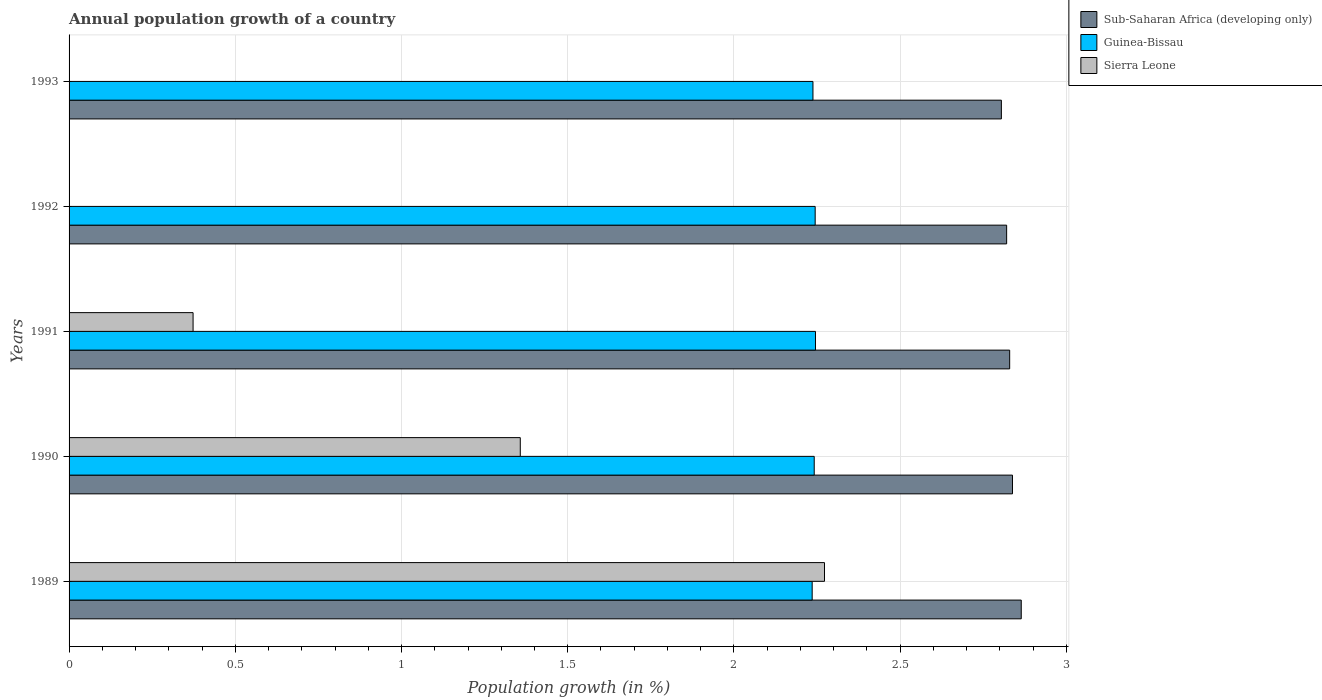How many different coloured bars are there?
Your response must be concise. 3. How many groups of bars are there?
Give a very brief answer. 5. Are the number of bars per tick equal to the number of legend labels?
Offer a very short reply. No. How many bars are there on the 3rd tick from the bottom?
Your response must be concise. 3. What is the label of the 5th group of bars from the top?
Your answer should be compact. 1989. In how many cases, is the number of bars for a given year not equal to the number of legend labels?
Keep it short and to the point. 2. What is the annual population growth in Guinea-Bissau in 1990?
Keep it short and to the point. 2.24. Across all years, what is the maximum annual population growth in Sub-Saharan Africa (developing only)?
Offer a terse response. 2.86. Across all years, what is the minimum annual population growth in Sierra Leone?
Make the answer very short. 0. What is the total annual population growth in Sierra Leone in the graph?
Provide a succinct answer. 4. What is the difference between the annual population growth in Sub-Saharan Africa (developing only) in 1989 and that in 1990?
Your answer should be compact. 0.03. What is the difference between the annual population growth in Sub-Saharan Africa (developing only) in 1990 and the annual population growth in Guinea-Bissau in 1989?
Your answer should be compact. 0.6. What is the average annual population growth in Sub-Saharan Africa (developing only) per year?
Give a very brief answer. 2.83. In the year 1991, what is the difference between the annual population growth in Guinea-Bissau and annual population growth in Sierra Leone?
Your response must be concise. 1.87. What is the ratio of the annual population growth in Sub-Saharan Africa (developing only) in 1989 to that in 1991?
Your answer should be compact. 1.01. Is the annual population growth in Guinea-Bissau in 1989 less than that in 1991?
Offer a terse response. Yes. What is the difference between the highest and the second highest annual population growth in Guinea-Bissau?
Your answer should be very brief. 0. What is the difference between the highest and the lowest annual population growth in Sub-Saharan Africa (developing only)?
Offer a terse response. 0.06. Is the sum of the annual population growth in Guinea-Bissau in 1992 and 1993 greater than the maximum annual population growth in Sub-Saharan Africa (developing only) across all years?
Your answer should be compact. Yes. Is it the case that in every year, the sum of the annual population growth in Guinea-Bissau and annual population growth in Sierra Leone is greater than the annual population growth in Sub-Saharan Africa (developing only)?
Give a very brief answer. No. How many bars are there?
Ensure brevity in your answer.  13. Are all the bars in the graph horizontal?
Provide a succinct answer. Yes. Where does the legend appear in the graph?
Your response must be concise. Top right. What is the title of the graph?
Ensure brevity in your answer.  Annual population growth of a country. What is the label or title of the X-axis?
Keep it short and to the point. Population growth (in %). What is the label or title of the Y-axis?
Provide a short and direct response. Years. What is the Population growth (in %) of Sub-Saharan Africa (developing only) in 1989?
Give a very brief answer. 2.86. What is the Population growth (in %) in Guinea-Bissau in 1989?
Offer a terse response. 2.24. What is the Population growth (in %) in Sierra Leone in 1989?
Give a very brief answer. 2.27. What is the Population growth (in %) in Sub-Saharan Africa (developing only) in 1990?
Provide a succinct answer. 2.84. What is the Population growth (in %) of Guinea-Bissau in 1990?
Offer a terse response. 2.24. What is the Population growth (in %) of Sierra Leone in 1990?
Offer a very short reply. 1.36. What is the Population growth (in %) of Sub-Saharan Africa (developing only) in 1991?
Your response must be concise. 2.83. What is the Population growth (in %) of Guinea-Bissau in 1991?
Make the answer very short. 2.25. What is the Population growth (in %) in Sierra Leone in 1991?
Offer a terse response. 0.37. What is the Population growth (in %) in Sub-Saharan Africa (developing only) in 1992?
Provide a succinct answer. 2.82. What is the Population growth (in %) in Guinea-Bissau in 1992?
Provide a succinct answer. 2.24. What is the Population growth (in %) of Sierra Leone in 1992?
Ensure brevity in your answer.  0. What is the Population growth (in %) in Sub-Saharan Africa (developing only) in 1993?
Your answer should be very brief. 2.8. What is the Population growth (in %) in Guinea-Bissau in 1993?
Your answer should be compact. 2.24. Across all years, what is the maximum Population growth (in %) of Sub-Saharan Africa (developing only)?
Offer a terse response. 2.86. Across all years, what is the maximum Population growth (in %) in Guinea-Bissau?
Provide a succinct answer. 2.25. Across all years, what is the maximum Population growth (in %) in Sierra Leone?
Provide a succinct answer. 2.27. Across all years, what is the minimum Population growth (in %) of Sub-Saharan Africa (developing only)?
Provide a succinct answer. 2.8. Across all years, what is the minimum Population growth (in %) in Guinea-Bissau?
Give a very brief answer. 2.24. What is the total Population growth (in %) in Sub-Saharan Africa (developing only) in the graph?
Offer a terse response. 14.16. What is the total Population growth (in %) in Guinea-Bissau in the graph?
Your response must be concise. 11.2. What is the total Population growth (in %) of Sierra Leone in the graph?
Provide a succinct answer. 4. What is the difference between the Population growth (in %) of Sub-Saharan Africa (developing only) in 1989 and that in 1990?
Keep it short and to the point. 0.03. What is the difference between the Population growth (in %) of Guinea-Bissau in 1989 and that in 1990?
Ensure brevity in your answer.  -0.01. What is the difference between the Population growth (in %) in Sierra Leone in 1989 and that in 1990?
Keep it short and to the point. 0.92. What is the difference between the Population growth (in %) in Sub-Saharan Africa (developing only) in 1989 and that in 1991?
Your answer should be very brief. 0.03. What is the difference between the Population growth (in %) of Guinea-Bissau in 1989 and that in 1991?
Provide a short and direct response. -0.01. What is the difference between the Population growth (in %) in Sierra Leone in 1989 and that in 1991?
Provide a short and direct response. 1.9. What is the difference between the Population growth (in %) of Sub-Saharan Africa (developing only) in 1989 and that in 1992?
Keep it short and to the point. 0.04. What is the difference between the Population growth (in %) of Guinea-Bissau in 1989 and that in 1992?
Ensure brevity in your answer.  -0.01. What is the difference between the Population growth (in %) of Sub-Saharan Africa (developing only) in 1989 and that in 1993?
Your response must be concise. 0.06. What is the difference between the Population growth (in %) in Guinea-Bissau in 1989 and that in 1993?
Offer a very short reply. -0. What is the difference between the Population growth (in %) of Sub-Saharan Africa (developing only) in 1990 and that in 1991?
Keep it short and to the point. 0.01. What is the difference between the Population growth (in %) of Guinea-Bissau in 1990 and that in 1991?
Your response must be concise. -0. What is the difference between the Population growth (in %) of Sierra Leone in 1990 and that in 1991?
Your answer should be compact. 0.98. What is the difference between the Population growth (in %) in Sub-Saharan Africa (developing only) in 1990 and that in 1992?
Your answer should be very brief. 0.02. What is the difference between the Population growth (in %) in Guinea-Bissau in 1990 and that in 1992?
Your answer should be very brief. -0. What is the difference between the Population growth (in %) of Sub-Saharan Africa (developing only) in 1990 and that in 1993?
Offer a very short reply. 0.03. What is the difference between the Population growth (in %) of Guinea-Bissau in 1990 and that in 1993?
Your answer should be very brief. 0. What is the difference between the Population growth (in %) in Sub-Saharan Africa (developing only) in 1991 and that in 1992?
Your answer should be compact. 0.01. What is the difference between the Population growth (in %) of Guinea-Bissau in 1991 and that in 1992?
Your answer should be very brief. 0. What is the difference between the Population growth (in %) of Sub-Saharan Africa (developing only) in 1991 and that in 1993?
Offer a terse response. 0.03. What is the difference between the Population growth (in %) of Guinea-Bissau in 1991 and that in 1993?
Offer a very short reply. 0.01. What is the difference between the Population growth (in %) of Sub-Saharan Africa (developing only) in 1992 and that in 1993?
Provide a short and direct response. 0.02. What is the difference between the Population growth (in %) of Guinea-Bissau in 1992 and that in 1993?
Your answer should be compact. 0.01. What is the difference between the Population growth (in %) in Sub-Saharan Africa (developing only) in 1989 and the Population growth (in %) in Guinea-Bissau in 1990?
Provide a succinct answer. 0.62. What is the difference between the Population growth (in %) in Sub-Saharan Africa (developing only) in 1989 and the Population growth (in %) in Sierra Leone in 1990?
Give a very brief answer. 1.51. What is the difference between the Population growth (in %) of Guinea-Bissau in 1989 and the Population growth (in %) of Sierra Leone in 1990?
Keep it short and to the point. 0.88. What is the difference between the Population growth (in %) of Sub-Saharan Africa (developing only) in 1989 and the Population growth (in %) of Guinea-Bissau in 1991?
Your response must be concise. 0.62. What is the difference between the Population growth (in %) in Sub-Saharan Africa (developing only) in 1989 and the Population growth (in %) in Sierra Leone in 1991?
Provide a short and direct response. 2.49. What is the difference between the Population growth (in %) in Guinea-Bissau in 1989 and the Population growth (in %) in Sierra Leone in 1991?
Provide a short and direct response. 1.86. What is the difference between the Population growth (in %) in Sub-Saharan Africa (developing only) in 1989 and the Population growth (in %) in Guinea-Bissau in 1992?
Provide a succinct answer. 0.62. What is the difference between the Population growth (in %) in Sub-Saharan Africa (developing only) in 1989 and the Population growth (in %) in Guinea-Bissau in 1993?
Give a very brief answer. 0.63. What is the difference between the Population growth (in %) of Sub-Saharan Africa (developing only) in 1990 and the Population growth (in %) of Guinea-Bissau in 1991?
Your answer should be very brief. 0.59. What is the difference between the Population growth (in %) in Sub-Saharan Africa (developing only) in 1990 and the Population growth (in %) in Sierra Leone in 1991?
Your answer should be very brief. 2.46. What is the difference between the Population growth (in %) of Guinea-Bissau in 1990 and the Population growth (in %) of Sierra Leone in 1991?
Keep it short and to the point. 1.87. What is the difference between the Population growth (in %) in Sub-Saharan Africa (developing only) in 1990 and the Population growth (in %) in Guinea-Bissau in 1992?
Provide a short and direct response. 0.59. What is the difference between the Population growth (in %) of Sub-Saharan Africa (developing only) in 1990 and the Population growth (in %) of Guinea-Bissau in 1993?
Keep it short and to the point. 0.6. What is the difference between the Population growth (in %) in Sub-Saharan Africa (developing only) in 1991 and the Population growth (in %) in Guinea-Bissau in 1992?
Provide a succinct answer. 0.59. What is the difference between the Population growth (in %) of Sub-Saharan Africa (developing only) in 1991 and the Population growth (in %) of Guinea-Bissau in 1993?
Offer a terse response. 0.59. What is the difference between the Population growth (in %) in Sub-Saharan Africa (developing only) in 1992 and the Population growth (in %) in Guinea-Bissau in 1993?
Your answer should be compact. 0.58. What is the average Population growth (in %) in Sub-Saharan Africa (developing only) per year?
Offer a very short reply. 2.83. What is the average Population growth (in %) of Guinea-Bissau per year?
Give a very brief answer. 2.24. What is the average Population growth (in %) in Sierra Leone per year?
Your answer should be very brief. 0.8. In the year 1989, what is the difference between the Population growth (in %) of Sub-Saharan Africa (developing only) and Population growth (in %) of Guinea-Bissau?
Make the answer very short. 0.63. In the year 1989, what is the difference between the Population growth (in %) of Sub-Saharan Africa (developing only) and Population growth (in %) of Sierra Leone?
Provide a short and direct response. 0.59. In the year 1989, what is the difference between the Population growth (in %) of Guinea-Bissau and Population growth (in %) of Sierra Leone?
Your answer should be compact. -0.04. In the year 1990, what is the difference between the Population growth (in %) of Sub-Saharan Africa (developing only) and Population growth (in %) of Guinea-Bissau?
Ensure brevity in your answer.  0.6. In the year 1990, what is the difference between the Population growth (in %) of Sub-Saharan Africa (developing only) and Population growth (in %) of Sierra Leone?
Your answer should be very brief. 1.48. In the year 1990, what is the difference between the Population growth (in %) of Guinea-Bissau and Population growth (in %) of Sierra Leone?
Give a very brief answer. 0.88. In the year 1991, what is the difference between the Population growth (in %) in Sub-Saharan Africa (developing only) and Population growth (in %) in Guinea-Bissau?
Provide a short and direct response. 0.58. In the year 1991, what is the difference between the Population growth (in %) of Sub-Saharan Africa (developing only) and Population growth (in %) of Sierra Leone?
Offer a terse response. 2.46. In the year 1991, what is the difference between the Population growth (in %) of Guinea-Bissau and Population growth (in %) of Sierra Leone?
Provide a succinct answer. 1.87. In the year 1992, what is the difference between the Population growth (in %) in Sub-Saharan Africa (developing only) and Population growth (in %) in Guinea-Bissau?
Ensure brevity in your answer.  0.58. In the year 1993, what is the difference between the Population growth (in %) of Sub-Saharan Africa (developing only) and Population growth (in %) of Guinea-Bissau?
Ensure brevity in your answer.  0.57. What is the ratio of the Population growth (in %) in Sub-Saharan Africa (developing only) in 1989 to that in 1990?
Offer a terse response. 1.01. What is the ratio of the Population growth (in %) of Guinea-Bissau in 1989 to that in 1990?
Make the answer very short. 1. What is the ratio of the Population growth (in %) of Sierra Leone in 1989 to that in 1990?
Ensure brevity in your answer.  1.67. What is the ratio of the Population growth (in %) in Sub-Saharan Africa (developing only) in 1989 to that in 1991?
Offer a terse response. 1.01. What is the ratio of the Population growth (in %) of Sierra Leone in 1989 to that in 1991?
Keep it short and to the point. 6.09. What is the ratio of the Population growth (in %) of Sub-Saharan Africa (developing only) in 1989 to that in 1992?
Your answer should be compact. 1.02. What is the ratio of the Population growth (in %) in Sub-Saharan Africa (developing only) in 1989 to that in 1993?
Provide a short and direct response. 1.02. What is the ratio of the Population growth (in %) in Guinea-Bissau in 1989 to that in 1993?
Your answer should be very brief. 1. What is the ratio of the Population growth (in %) in Sub-Saharan Africa (developing only) in 1990 to that in 1991?
Ensure brevity in your answer.  1. What is the ratio of the Population growth (in %) in Sierra Leone in 1990 to that in 1991?
Provide a short and direct response. 3.64. What is the ratio of the Population growth (in %) of Sub-Saharan Africa (developing only) in 1990 to that in 1992?
Your answer should be very brief. 1.01. What is the ratio of the Population growth (in %) of Sub-Saharan Africa (developing only) in 1990 to that in 1993?
Provide a succinct answer. 1.01. What is the ratio of the Population growth (in %) of Sub-Saharan Africa (developing only) in 1991 to that in 1992?
Your answer should be compact. 1. What is the ratio of the Population growth (in %) in Guinea-Bissau in 1991 to that in 1992?
Give a very brief answer. 1. What is the ratio of the Population growth (in %) in Sub-Saharan Africa (developing only) in 1991 to that in 1993?
Keep it short and to the point. 1.01. What is the ratio of the Population growth (in %) of Sub-Saharan Africa (developing only) in 1992 to that in 1993?
Give a very brief answer. 1.01. What is the difference between the highest and the second highest Population growth (in %) in Sub-Saharan Africa (developing only)?
Keep it short and to the point. 0.03. What is the difference between the highest and the second highest Population growth (in %) in Guinea-Bissau?
Make the answer very short. 0. What is the difference between the highest and the second highest Population growth (in %) of Sierra Leone?
Provide a succinct answer. 0.92. What is the difference between the highest and the lowest Population growth (in %) in Sub-Saharan Africa (developing only)?
Keep it short and to the point. 0.06. What is the difference between the highest and the lowest Population growth (in %) in Sierra Leone?
Ensure brevity in your answer.  2.27. 